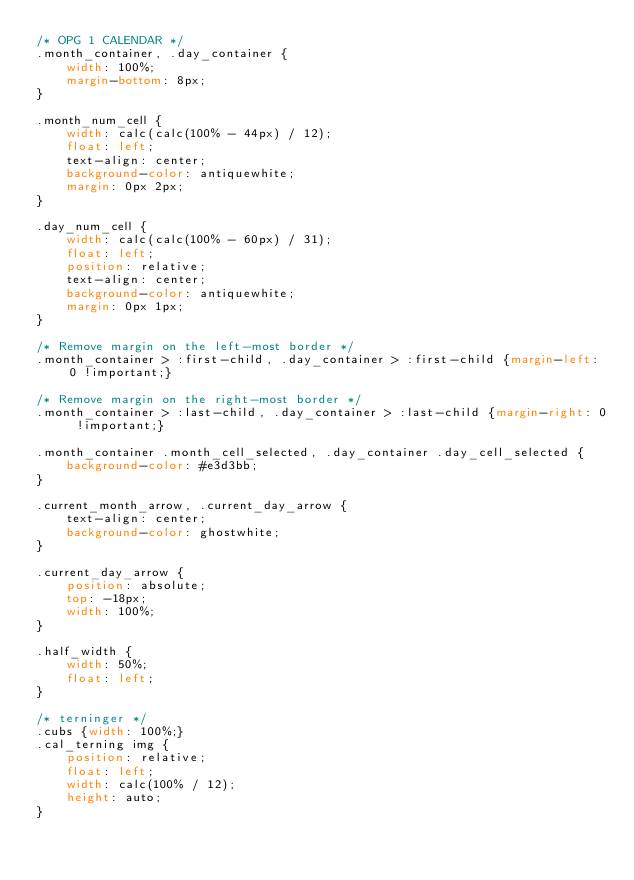<code> <loc_0><loc_0><loc_500><loc_500><_CSS_>/* OPG 1 CALENDAR */
.month_container, .day_container {
    width: 100%;
    margin-bottom: 8px;
}

.month_num_cell {
    width: calc(calc(100% - 44px) / 12);
    float: left;
    text-align: center;
    background-color: antiquewhite;
    margin: 0px 2px;
}

.day_num_cell {
    width: calc(calc(100% - 60px) / 31);
    float: left;
    position: relative;
    text-align: center;
    background-color: antiquewhite;
    margin: 0px 1px;
}

/* Remove margin on the left-most border */
.month_container > :first-child, .day_container > :first-child {margin-left: 0 !important;}

/* Remove margin on the right-most border */
.month_container > :last-child, .day_container > :last-child {margin-right: 0 !important;}

.month_container .month_cell_selected, .day_container .day_cell_selected {
    background-color: #e3d3bb;
}

.current_month_arrow, .current_day_arrow {
    text-align: center;
    background-color: ghostwhite;
}

.current_day_arrow {
    position: absolute;
    top: -18px;
    width: 100%;
}

.half_width {
    width: 50%;
    float: left;
}

/* terninger */
.cubs {width: 100%;}
.cal_terning img {
    position: relative;
    float: left;
    width: calc(100% / 12);
    height: auto;
}</code> 